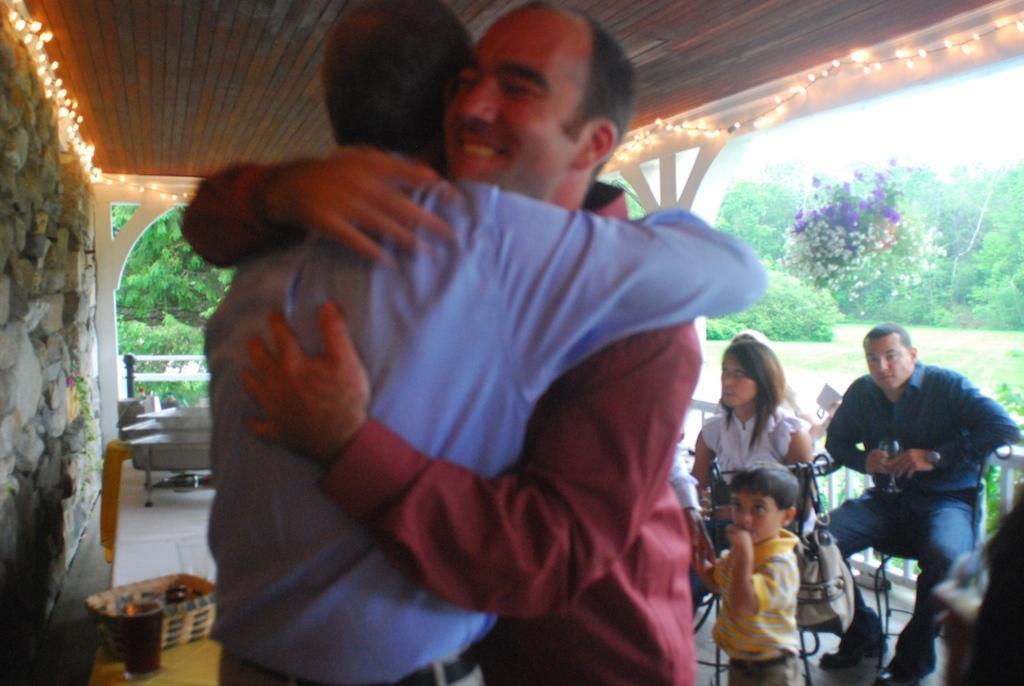How would you summarize this image in a sentence or two? In this image in front there are two persons hugging each other. Behind them there is a table and on top of the table there are few objects. On the right side of the image there are people sitting on the chairs. On the left side of the image there is a wall. There are lights. In the background of the image there are trees and sky. At the bottom of the image there is a floor. 